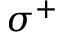<formula> <loc_0><loc_0><loc_500><loc_500>\sigma ^ { + }</formula> 